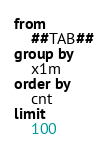<code> <loc_0><loc_0><loc_500><loc_500><_SQL_>from
    ##TAB##
group by
    x1m
order by 
    cnt
limit 
    100</code> 